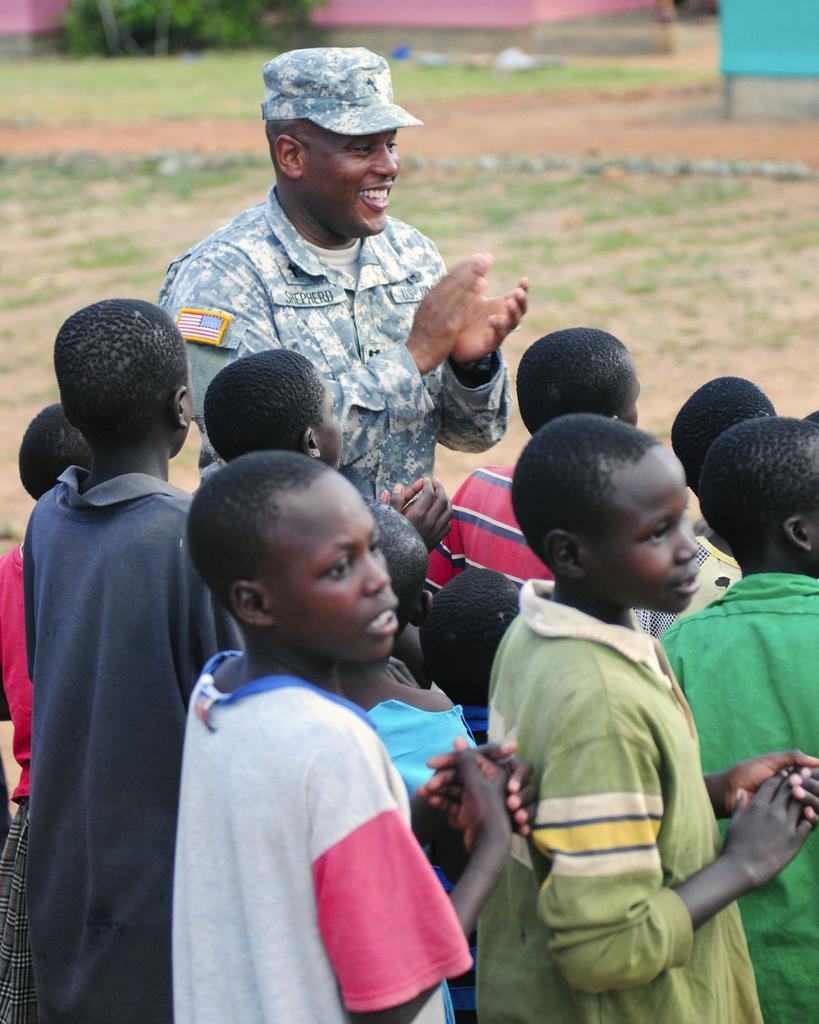What is the surface that the people are standing on in the image? The people are standing on the ground in the image. What type of natural elements can be seen in the image? There are stones, grass, and trees in the image. What type of man-made structure is present in the image? There is a wall in the image. What other objects are present on the ground in the image? There are other objects on the ground in the image. What type of tooth is visible in the image? There is no tooth visible in the image. What position are the trees in the image? The trees are not in a specific position; they are simply present in the image. 